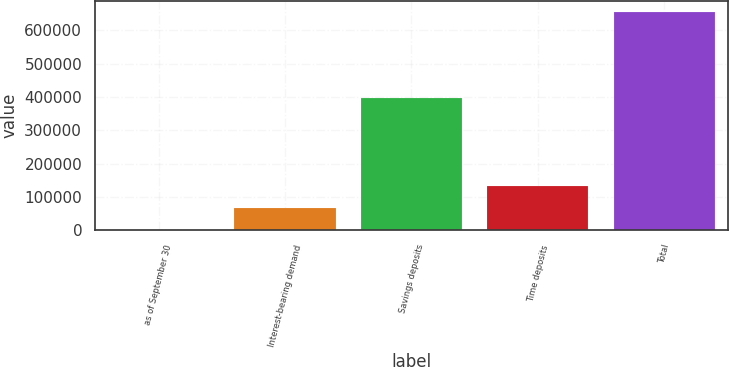Convert chart to OTSL. <chart><loc_0><loc_0><loc_500><loc_500><bar_chart><fcel>as of September 30<fcel>Interest-bearing demand<fcel>Savings deposits<fcel>Time deposits<fcel>Total<nl><fcel>2010<fcel>67383.8<fcel>397078<fcel>132758<fcel>655748<nl></chart> 